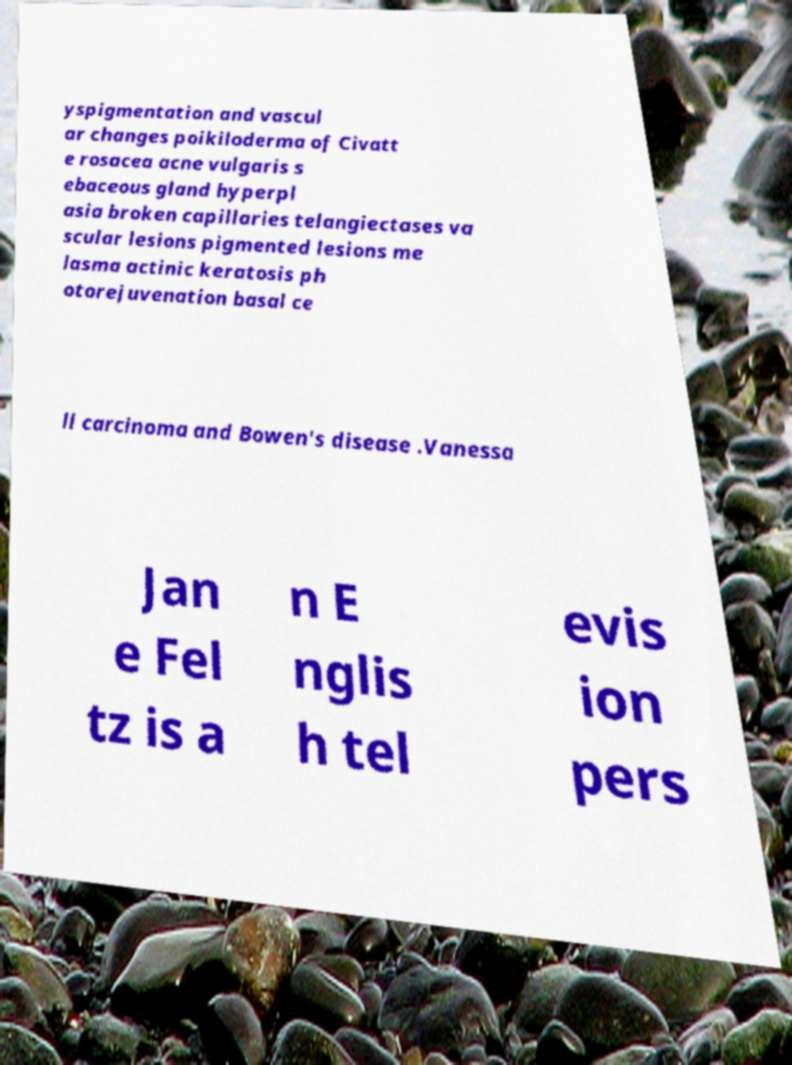Please read and relay the text visible in this image. What does it say? yspigmentation and vascul ar changes poikiloderma of Civatt e rosacea acne vulgaris s ebaceous gland hyperpl asia broken capillaries telangiectases va scular lesions pigmented lesions me lasma actinic keratosis ph otorejuvenation basal ce ll carcinoma and Bowen's disease .Vanessa Jan e Fel tz is a n E nglis h tel evis ion pers 